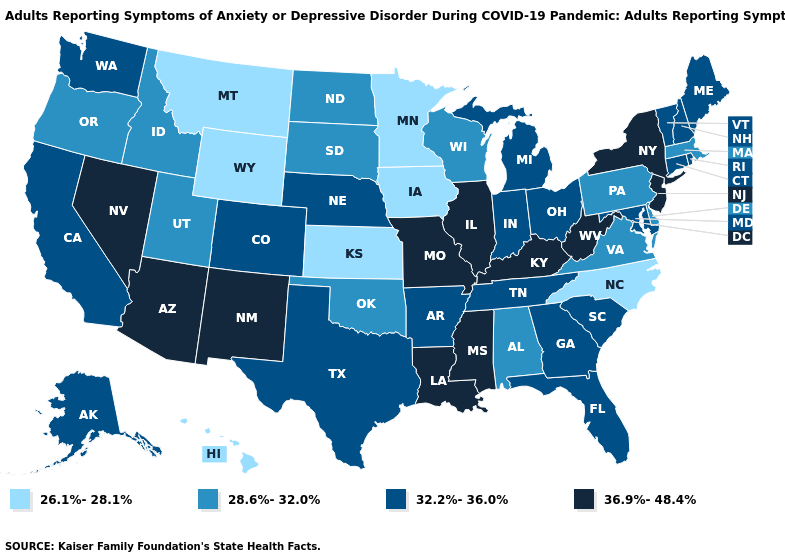What is the value of Oklahoma?
Keep it brief. 28.6%-32.0%. Among the states that border Nebraska , which have the lowest value?
Short answer required. Iowa, Kansas, Wyoming. Among the states that border Alabama , which have the lowest value?
Concise answer only. Florida, Georgia, Tennessee. What is the value of South Carolina?
Short answer required. 32.2%-36.0%. Name the states that have a value in the range 26.1%-28.1%?
Concise answer only. Hawaii, Iowa, Kansas, Minnesota, Montana, North Carolina, Wyoming. Among the states that border Iowa , does Minnesota have the lowest value?
Keep it brief. Yes. What is the lowest value in states that border South Dakota?
Write a very short answer. 26.1%-28.1%. What is the value of Pennsylvania?
Answer briefly. 28.6%-32.0%. Among the states that border Arizona , does Utah have the lowest value?
Concise answer only. Yes. Does the map have missing data?
Write a very short answer. No. What is the value of Texas?
Keep it brief. 32.2%-36.0%. Does the map have missing data?
Write a very short answer. No. Which states have the lowest value in the MidWest?
Answer briefly. Iowa, Kansas, Minnesota. What is the value of Hawaii?
Be succinct. 26.1%-28.1%. What is the highest value in the South ?
Short answer required. 36.9%-48.4%. 